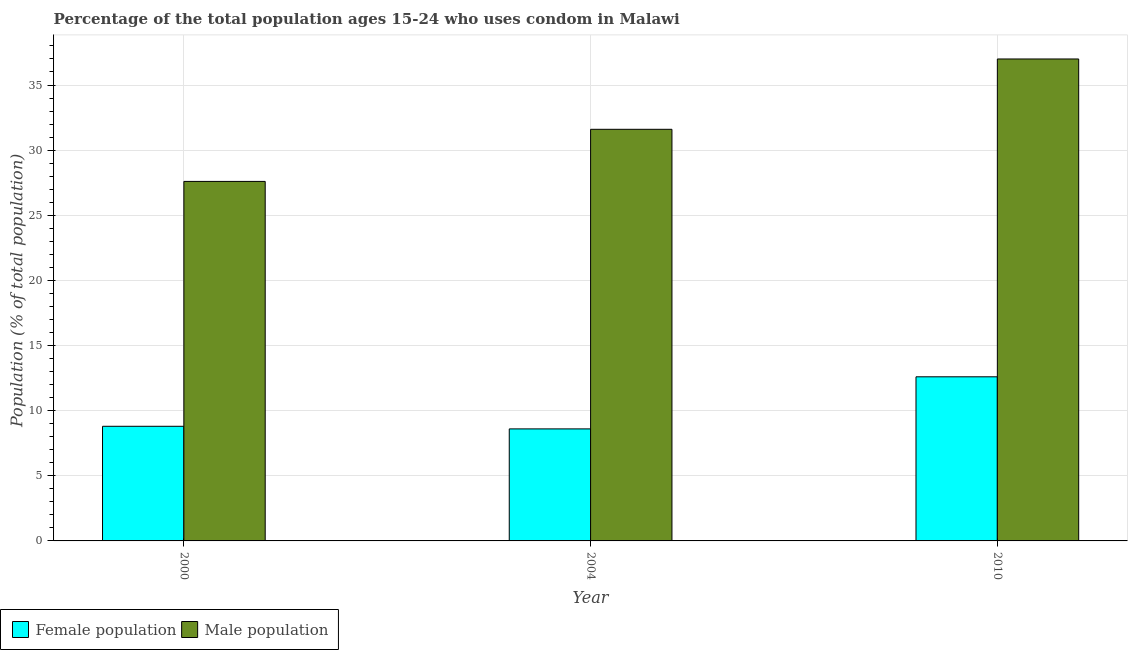Are the number of bars per tick equal to the number of legend labels?
Your answer should be compact. Yes. What is the label of the 1st group of bars from the left?
Your answer should be compact. 2000. What is the male population in 2004?
Ensure brevity in your answer.  31.6. Across all years, what is the minimum male population?
Give a very brief answer. 27.6. In which year was the female population maximum?
Your answer should be very brief. 2010. What is the total male population in the graph?
Ensure brevity in your answer.  96.2. What is the difference between the male population in 2000 and that in 2010?
Give a very brief answer. -9.4. What is the difference between the female population in 2010 and the male population in 2000?
Ensure brevity in your answer.  3.8. What is the ratio of the female population in 2004 to that in 2010?
Give a very brief answer. 0.68. Is the difference between the male population in 2000 and 2004 greater than the difference between the female population in 2000 and 2004?
Make the answer very short. No. What is the difference between the highest and the second highest female population?
Offer a terse response. 3.8. What is the difference between the highest and the lowest male population?
Give a very brief answer. 9.4. What does the 1st bar from the left in 2010 represents?
Provide a short and direct response. Female population. What does the 2nd bar from the right in 2004 represents?
Make the answer very short. Female population. Are all the bars in the graph horizontal?
Offer a very short reply. No. How many years are there in the graph?
Offer a terse response. 3. What is the difference between two consecutive major ticks on the Y-axis?
Offer a terse response. 5. Are the values on the major ticks of Y-axis written in scientific E-notation?
Ensure brevity in your answer.  No. Does the graph contain grids?
Keep it short and to the point. Yes. Where does the legend appear in the graph?
Offer a very short reply. Bottom left. How many legend labels are there?
Keep it short and to the point. 2. How are the legend labels stacked?
Offer a very short reply. Horizontal. What is the title of the graph?
Give a very brief answer. Percentage of the total population ages 15-24 who uses condom in Malawi. What is the label or title of the Y-axis?
Offer a very short reply. Population (% of total population) . What is the Population (% of total population)  in Male population in 2000?
Provide a short and direct response. 27.6. What is the Population (% of total population)  in Male population in 2004?
Keep it short and to the point. 31.6. What is the Population (% of total population)  in Female population in 2010?
Provide a short and direct response. 12.6. Across all years, what is the maximum Population (% of total population)  of Male population?
Give a very brief answer. 37. Across all years, what is the minimum Population (% of total population)  of Male population?
Give a very brief answer. 27.6. What is the total Population (% of total population)  in Male population in the graph?
Offer a very short reply. 96.2. What is the difference between the Population (% of total population)  in Male population in 2000 and that in 2004?
Your answer should be very brief. -4. What is the difference between the Population (% of total population)  of Female population in 2000 and that in 2010?
Offer a very short reply. -3.8. What is the difference between the Population (% of total population)  in Male population in 2000 and that in 2010?
Offer a very short reply. -9.4. What is the difference between the Population (% of total population)  in Female population in 2004 and that in 2010?
Ensure brevity in your answer.  -4. What is the difference between the Population (% of total population)  of Female population in 2000 and the Population (% of total population)  of Male population in 2004?
Offer a terse response. -22.8. What is the difference between the Population (% of total population)  in Female population in 2000 and the Population (% of total population)  in Male population in 2010?
Your answer should be compact. -28.2. What is the difference between the Population (% of total population)  in Female population in 2004 and the Population (% of total population)  in Male population in 2010?
Your answer should be very brief. -28.4. What is the average Population (% of total population)  of Male population per year?
Give a very brief answer. 32.07. In the year 2000, what is the difference between the Population (% of total population)  in Female population and Population (% of total population)  in Male population?
Ensure brevity in your answer.  -18.8. In the year 2010, what is the difference between the Population (% of total population)  of Female population and Population (% of total population)  of Male population?
Make the answer very short. -24.4. What is the ratio of the Population (% of total population)  in Female population in 2000 to that in 2004?
Ensure brevity in your answer.  1.02. What is the ratio of the Population (% of total population)  of Male population in 2000 to that in 2004?
Your answer should be very brief. 0.87. What is the ratio of the Population (% of total population)  in Female population in 2000 to that in 2010?
Offer a very short reply. 0.7. What is the ratio of the Population (% of total population)  in Male population in 2000 to that in 2010?
Provide a short and direct response. 0.75. What is the ratio of the Population (% of total population)  in Female population in 2004 to that in 2010?
Provide a succinct answer. 0.68. What is the ratio of the Population (% of total population)  of Male population in 2004 to that in 2010?
Your response must be concise. 0.85. What is the difference between the highest and the second highest Population (% of total population)  of Female population?
Your response must be concise. 3.8. What is the difference between the highest and the lowest Population (% of total population)  of Male population?
Provide a short and direct response. 9.4. 